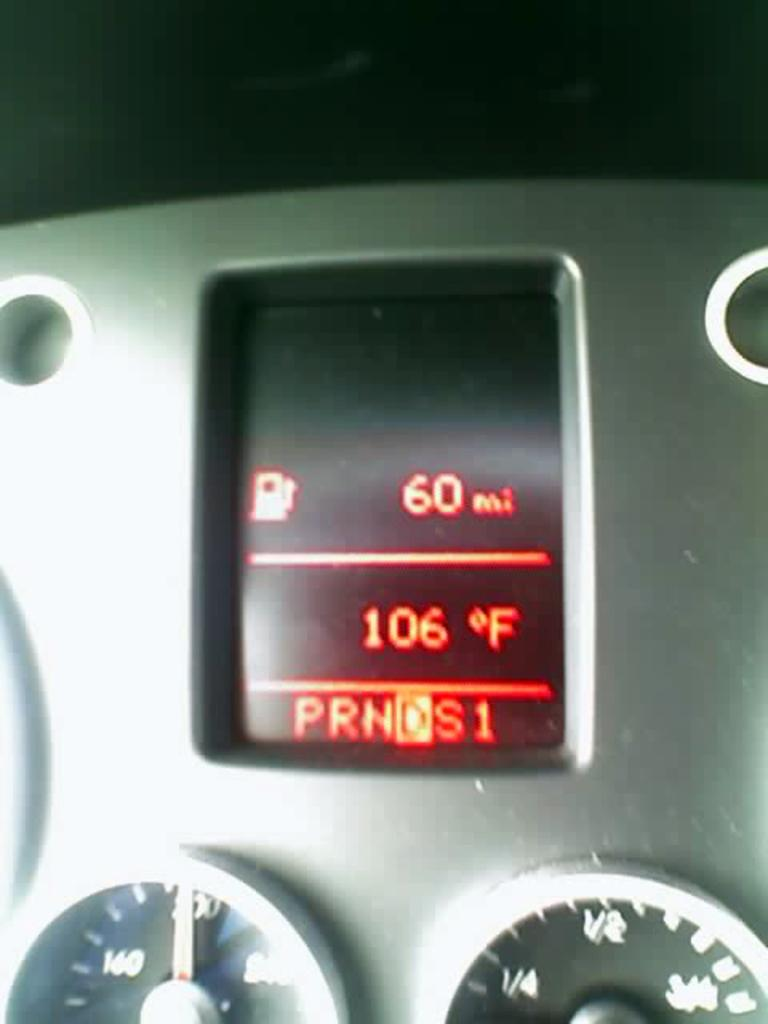What is the main object in the image? There is a device in the image. What features does the device have? The device has meters and a screen. What can be seen on the screen of the device? The screen displays text. What type of skin is visible on the device in the image? There is no skin visible on the device in the image; it is an electronic device with a screen and meters. 